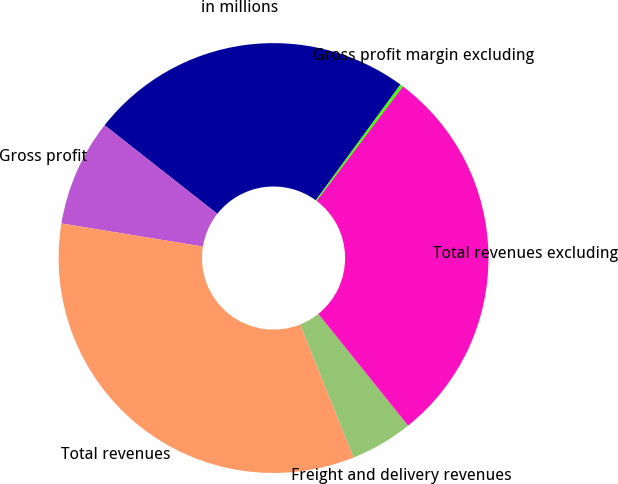Convert chart. <chart><loc_0><loc_0><loc_500><loc_500><pie_chart><fcel>in millions<fcel>Gross profit<fcel>Total revenues<fcel>Freight and delivery revenues<fcel>Total revenues excluding<fcel>Gross profit margin excluding<nl><fcel>24.45%<fcel>8.03%<fcel>33.65%<fcel>4.69%<fcel>28.96%<fcel>0.22%<nl></chart> 